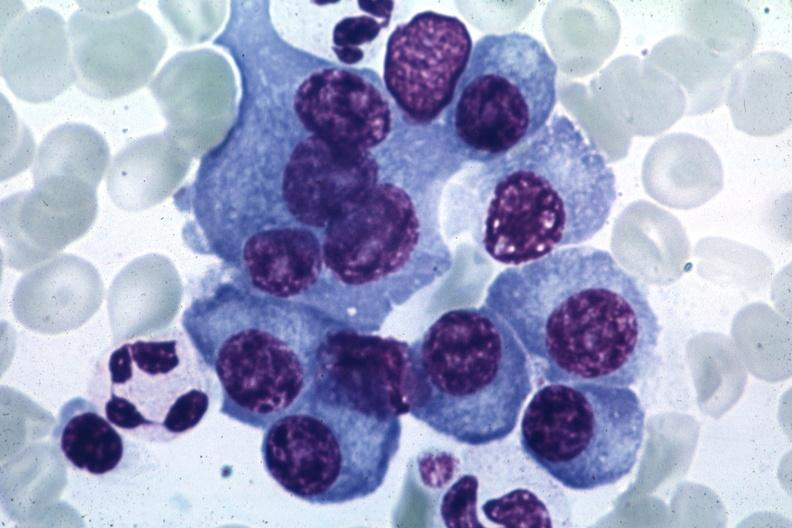what does this image show?
Answer the question using a single word or phrase. Typical cells with some pleomorphism suspicious for multiple myeloma source unknown 